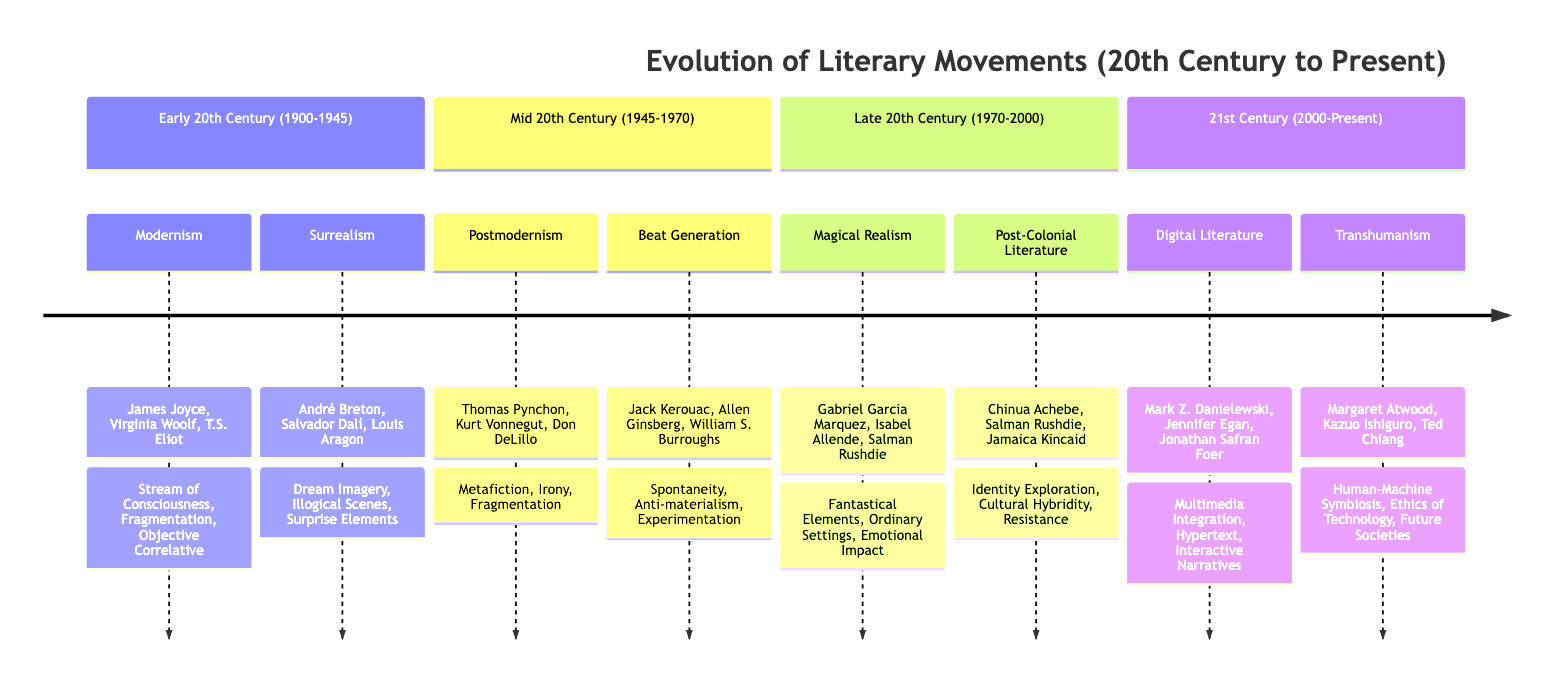What literary movement is associated with James Joyce? The diagram shows that James Joyce is a key figure of the Modernism movement during the Early 20th Century (1900-1945).
Answer: Modernism How many movements are listed for the Late 20th Century? By examining the section for the Late 20th Century (1970-2000), there are two movements listed: Magical Realism and Post-Colonial Literature.
Answer: 2 Which movement features "Human-Machine Symbiosis"? The timeline indicates that the concept of "Human-Machine Symbiosis" is a feature of the Transhumanism movement in the 21st Century (2000-Present).
Answer: Transhumanism Who are the key figures of the Beat Generation? The diagram lists Jack Kerouac, Allen Ginsberg, and William S. Burroughs as key figures associated with the Beat Generation movement in the Mid 20th Century (1945-1970).
Answer: Jack Kerouac, Allen Ginsberg, William S. Burroughs What are the features of Postmodernism? The diagram identifies Metafiction, Irony, and Fragmentation as the features of the Postmodernism movement during the Mid 20th Century (1945-1970).
Answer: Metafiction, Irony, Fragmentation What literary movement emerged in the Early 20th Century that incorporates Dream Imagery? The Surrealism movement, which is part of the Early 20th Century (1900-1945) section of the diagram, incorporates Dream Imagery as one of its features.
Answer: Surrealism Which movement is characterized by "Emotional Impact"? In the Late 20th Century (1970-2000) section of the diagram, the Magical Realism movement is noted for its characteristic feature of Emotional Impact.
Answer: Magical Realism What does the 21st Century (2000-Present) encompass in terms of literary movements? The diagram outlines two movements for the 21st Century: Digital Literature and Transhumanism, highlighting the evolution of literary themes in this era.
Answer: Digital Literature, Transhumanism 